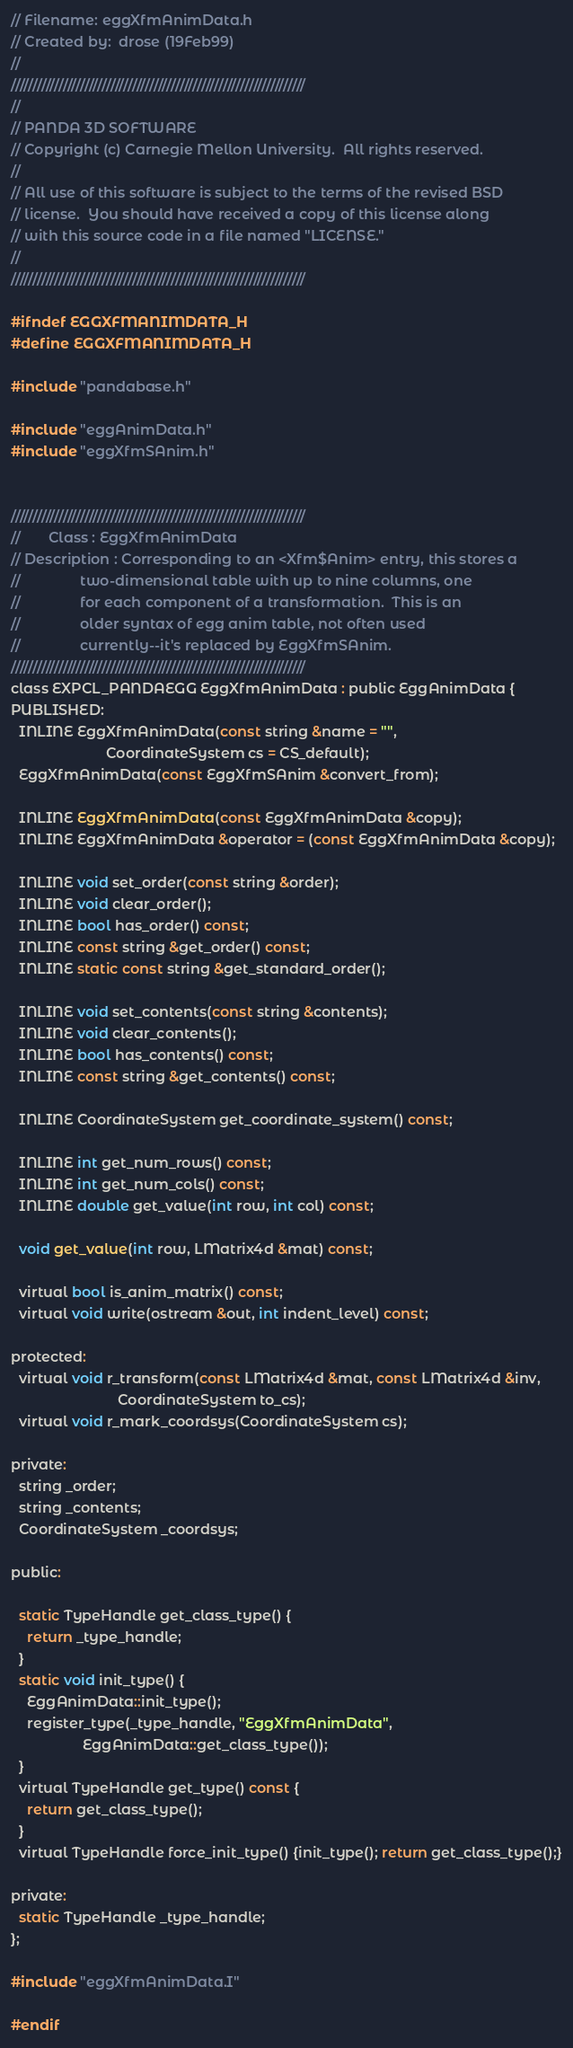Convert code to text. <code><loc_0><loc_0><loc_500><loc_500><_C_>// Filename: eggXfmAnimData.h
// Created by:  drose (19Feb99)
//
////////////////////////////////////////////////////////////////////
//
// PANDA 3D SOFTWARE
// Copyright (c) Carnegie Mellon University.  All rights reserved.
//
// All use of this software is subject to the terms of the revised BSD
// license.  You should have received a copy of this license along
// with this source code in a file named "LICENSE."
//
////////////////////////////////////////////////////////////////////

#ifndef EGGXFMANIMDATA_H
#define EGGXFMANIMDATA_H

#include "pandabase.h"

#include "eggAnimData.h"
#include "eggXfmSAnim.h"


////////////////////////////////////////////////////////////////////
//       Class : EggXfmAnimData
// Description : Corresponding to an <Xfm$Anim> entry, this stores a
//               two-dimensional table with up to nine columns, one
//               for each component of a transformation.  This is an
//               older syntax of egg anim table, not often used
//               currently--it's replaced by EggXfmSAnim.
////////////////////////////////////////////////////////////////////
class EXPCL_PANDAEGG EggXfmAnimData : public EggAnimData {
PUBLISHED:
  INLINE EggXfmAnimData(const string &name = "",
                        CoordinateSystem cs = CS_default);
  EggXfmAnimData(const EggXfmSAnim &convert_from);

  INLINE EggXfmAnimData(const EggXfmAnimData &copy);
  INLINE EggXfmAnimData &operator = (const EggXfmAnimData &copy);

  INLINE void set_order(const string &order);
  INLINE void clear_order();
  INLINE bool has_order() const;
  INLINE const string &get_order() const;
  INLINE static const string &get_standard_order();

  INLINE void set_contents(const string &contents);
  INLINE void clear_contents();
  INLINE bool has_contents() const;
  INLINE const string &get_contents() const;

  INLINE CoordinateSystem get_coordinate_system() const;

  INLINE int get_num_rows() const;
  INLINE int get_num_cols() const;
  INLINE double get_value(int row, int col) const;

  void get_value(int row, LMatrix4d &mat) const;

  virtual bool is_anim_matrix() const;
  virtual void write(ostream &out, int indent_level) const;

protected:
  virtual void r_transform(const LMatrix4d &mat, const LMatrix4d &inv,
                           CoordinateSystem to_cs);
  virtual void r_mark_coordsys(CoordinateSystem cs);

private:
  string _order;
  string _contents;
  CoordinateSystem _coordsys;

public:

  static TypeHandle get_class_type() {
    return _type_handle;
  }
  static void init_type() {
    EggAnimData::init_type();
    register_type(_type_handle, "EggXfmAnimData",
                  EggAnimData::get_class_type());
  }
  virtual TypeHandle get_type() const {
    return get_class_type();
  }
  virtual TypeHandle force_init_type() {init_type(); return get_class_type();}

private:
  static TypeHandle _type_handle;
};

#include "eggXfmAnimData.I"

#endif

</code> 